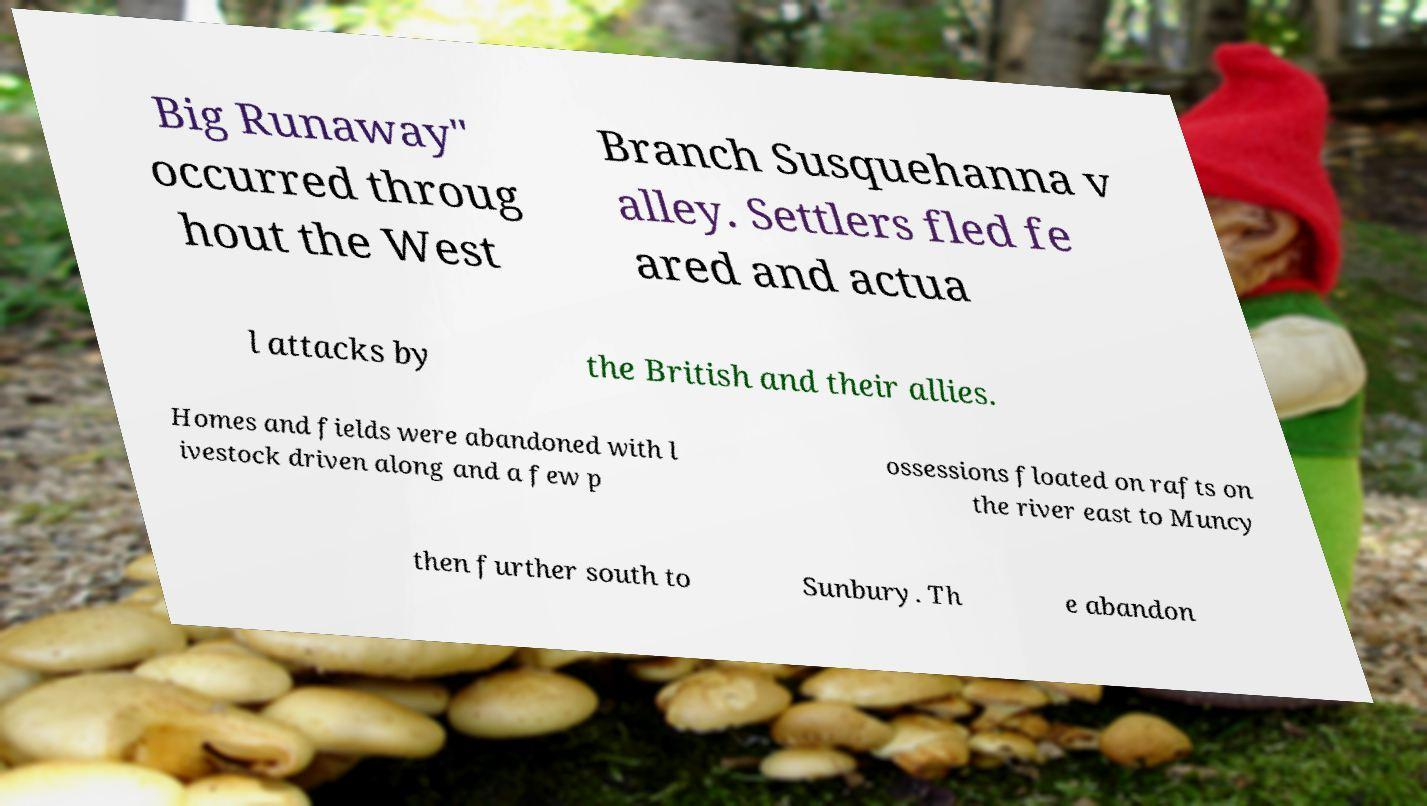Can you accurately transcribe the text from the provided image for me? Big Runaway" occurred throug hout the West Branch Susquehanna v alley. Settlers fled fe ared and actua l attacks by the British and their allies. Homes and fields were abandoned with l ivestock driven along and a few p ossessions floated on rafts on the river east to Muncy then further south to Sunbury. Th e abandon 